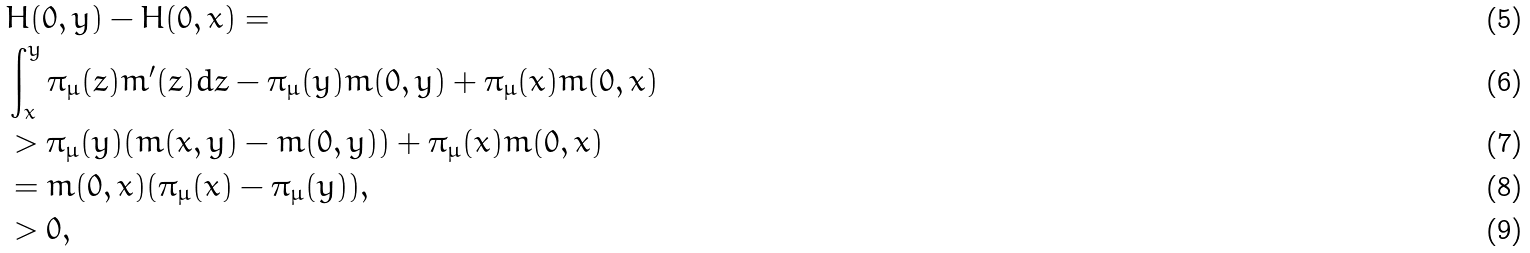<formula> <loc_0><loc_0><loc_500><loc_500>& H ( 0 , y ) - H ( 0 , x ) = \\ & \int _ { x } ^ { y } \pi _ { \mu } ( z ) m ^ { \prime } ( z ) d z - \pi _ { \mu } ( y ) m ( 0 , y ) + \pi _ { \mu } ( x ) m ( 0 , x ) \\ & > \pi _ { \mu } ( y ) ( m ( x , y ) - m ( 0 , y ) ) + \pi _ { \mu } ( x ) m ( 0 , x ) \\ & = m ( 0 , x ) ( \pi _ { \mu } ( x ) - \pi _ { \mu } ( y ) ) , \\ & > 0 ,</formula> 